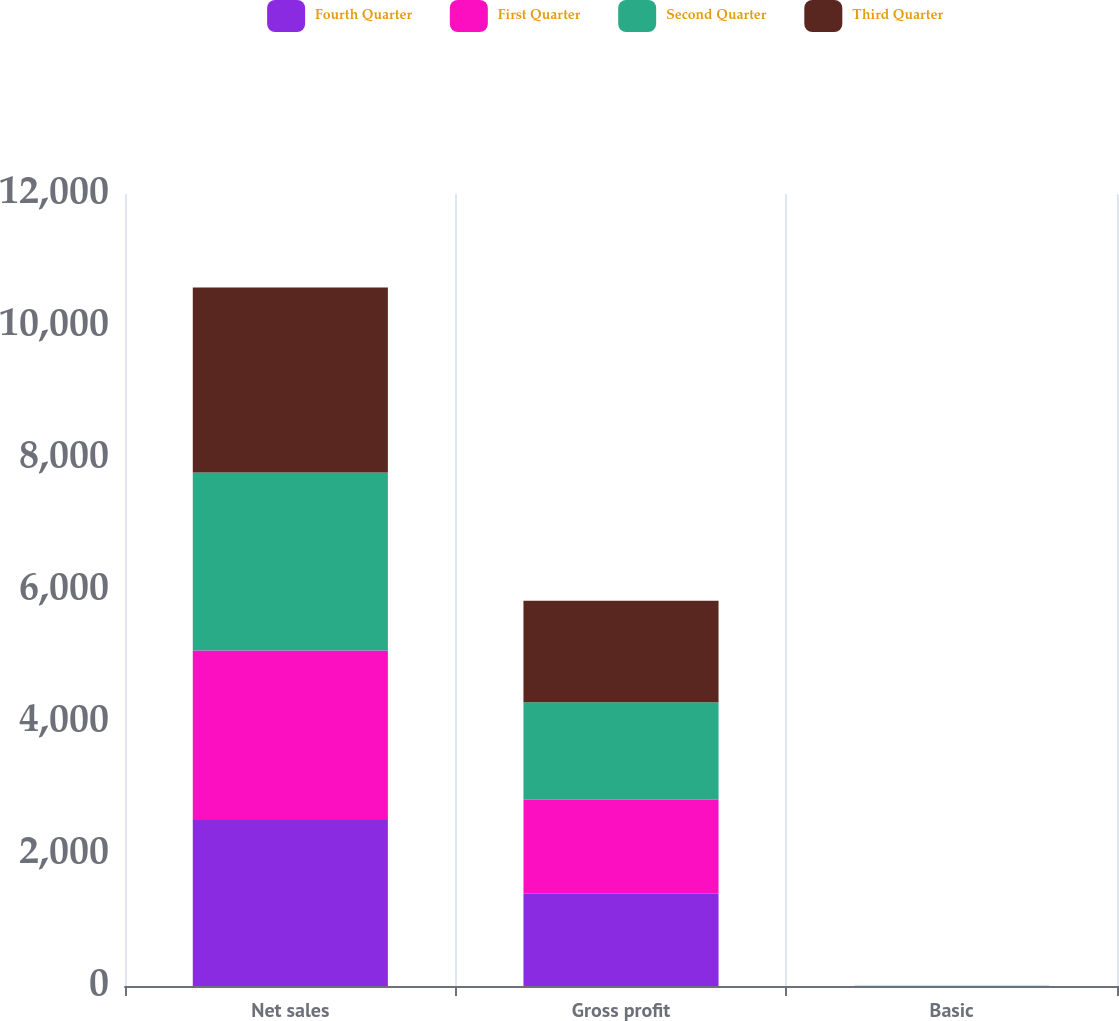<chart> <loc_0><loc_0><loc_500><loc_500><stacked_bar_chart><ecel><fcel>Net sales<fcel>Gross profit<fcel>Basic<nl><fcel>Fourth Quarter<fcel>2513.5<fcel>1399.6<fcel>0.62<nl><fcel>First Quarter<fcel>2571.7<fcel>1423.6<fcel>0.69<nl><fcel>Second Quarter<fcel>2695.7<fcel>1476.7<fcel>0.61<nl><fcel>Third Quarter<fcel>2803.3<fcel>1537.1<fcel>0.53<nl></chart> 